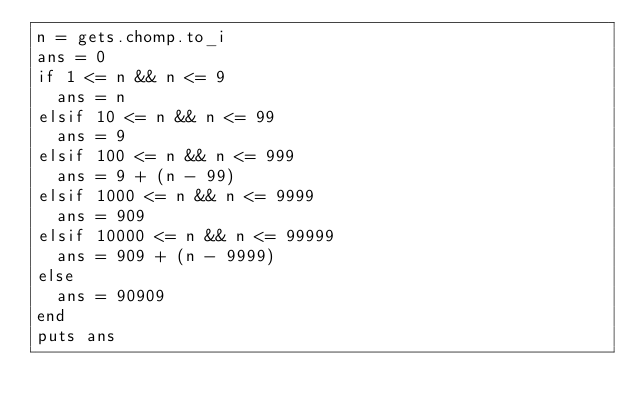Convert code to text. <code><loc_0><loc_0><loc_500><loc_500><_Ruby_>n = gets.chomp.to_i
ans = 0
if 1 <= n && n <= 9
  ans = n
elsif 10 <= n && n <= 99
  ans = 9
elsif 100 <= n && n <= 999
  ans = 9 + (n - 99)
elsif 1000 <= n && n <= 9999
  ans = 909
elsif 10000 <= n && n <= 99999
  ans = 909 + (n - 9999)
else
  ans = 90909
end
puts ans</code> 